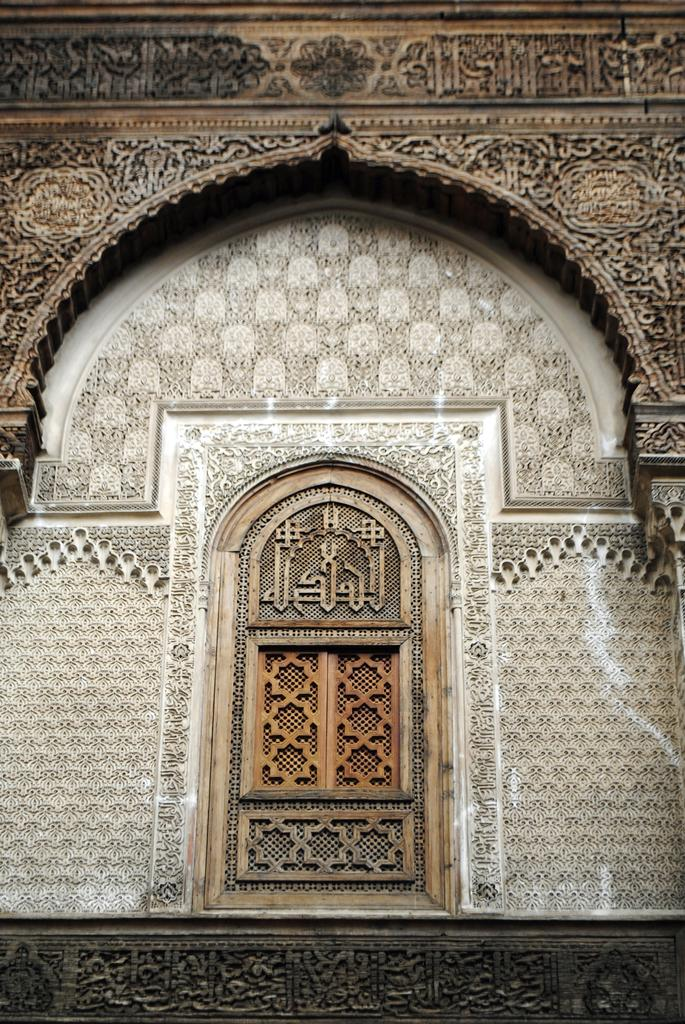What type of structure can be seen in the image? There is a wall in the image. What is unique about the wall? The wall has carvings on it. What other feature is present in the image? There is a door in the image. What is written on the door? The door has text on it. Are there any similarities between the door and the wall? Yes, the door also has carvings on it. What type of rod can be seen holding up the door in the image? There is no rod visible in the image holding up the door. 